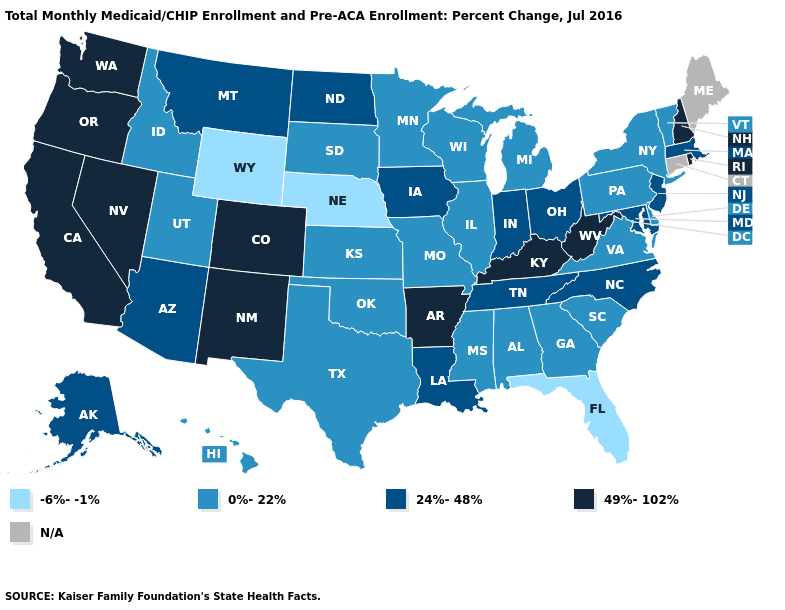Which states have the lowest value in the Northeast?
Short answer required. New York, Pennsylvania, Vermont. Name the states that have a value in the range 0%-22%?
Give a very brief answer. Alabama, Delaware, Georgia, Hawaii, Idaho, Illinois, Kansas, Michigan, Minnesota, Mississippi, Missouri, New York, Oklahoma, Pennsylvania, South Carolina, South Dakota, Texas, Utah, Vermont, Virginia, Wisconsin. What is the value of Hawaii?
Short answer required. 0%-22%. Which states have the lowest value in the USA?
Be succinct. Florida, Nebraska, Wyoming. Does the map have missing data?
Write a very short answer. Yes. Does Minnesota have the lowest value in the MidWest?
Answer briefly. No. Does the first symbol in the legend represent the smallest category?
Short answer required. Yes. How many symbols are there in the legend?
Give a very brief answer. 5. What is the value of Hawaii?
Short answer required. 0%-22%. Among the states that border Wisconsin , which have the lowest value?
Quick response, please. Illinois, Michigan, Minnesota. What is the lowest value in states that border West Virginia?
Give a very brief answer. 0%-22%. What is the highest value in states that border Connecticut?
Keep it brief. 49%-102%. Which states hav the highest value in the South?
Answer briefly. Arkansas, Kentucky, West Virginia. What is the value of Massachusetts?
Write a very short answer. 24%-48%. What is the value of Tennessee?
Short answer required. 24%-48%. 